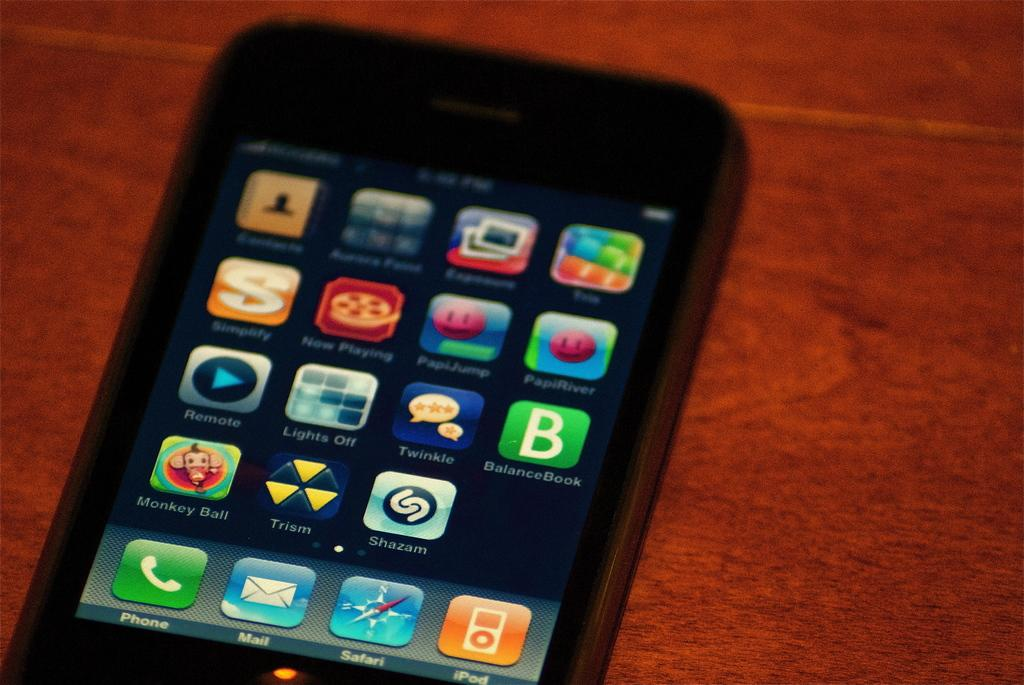<image>
Render a clear and concise summary of the photo. An iPhone is shown sitting on a wooden background with the main screen showing apps such as Shazam and BalanceBook. 